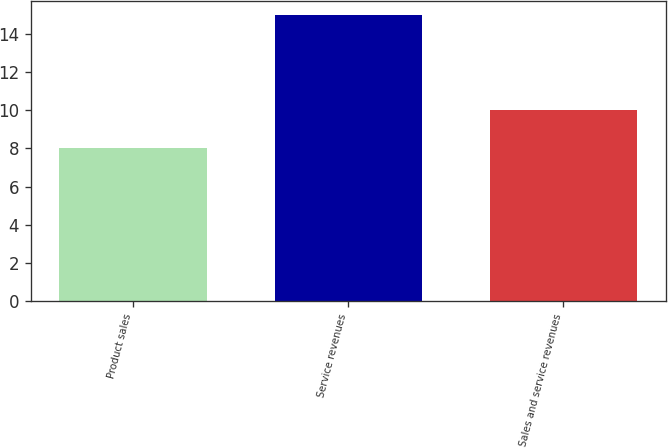Convert chart. <chart><loc_0><loc_0><loc_500><loc_500><bar_chart><fcel>Product sales<fcel>Service revenues<fcel>Sales and service revenues<nl><fcel>8<fcel>15<fcel>10<nl></chart> 